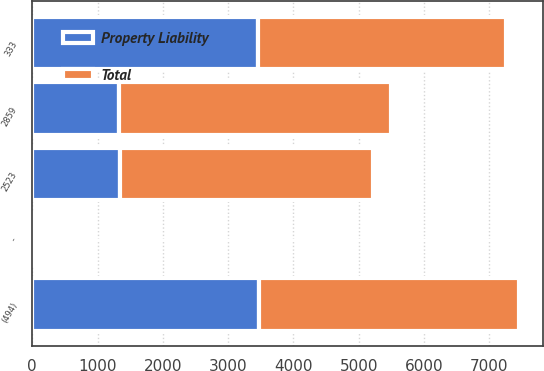<chart> <loc_0><loc_0><loc_500><loc_500><stacked_bar_chart><ecel><fcel>2859<fcel>-<fcel>333<fcel>(494)<fcel>2523<nl><fcel>Property Liability<fcel>1321<fcel>42<fcel>3462<fcel>3477<fcel>1348<nl><fcel>Total<fcel>4180<fcel>42<fcel>3795<fcel>3971<fcel>3871<nl></chart> 